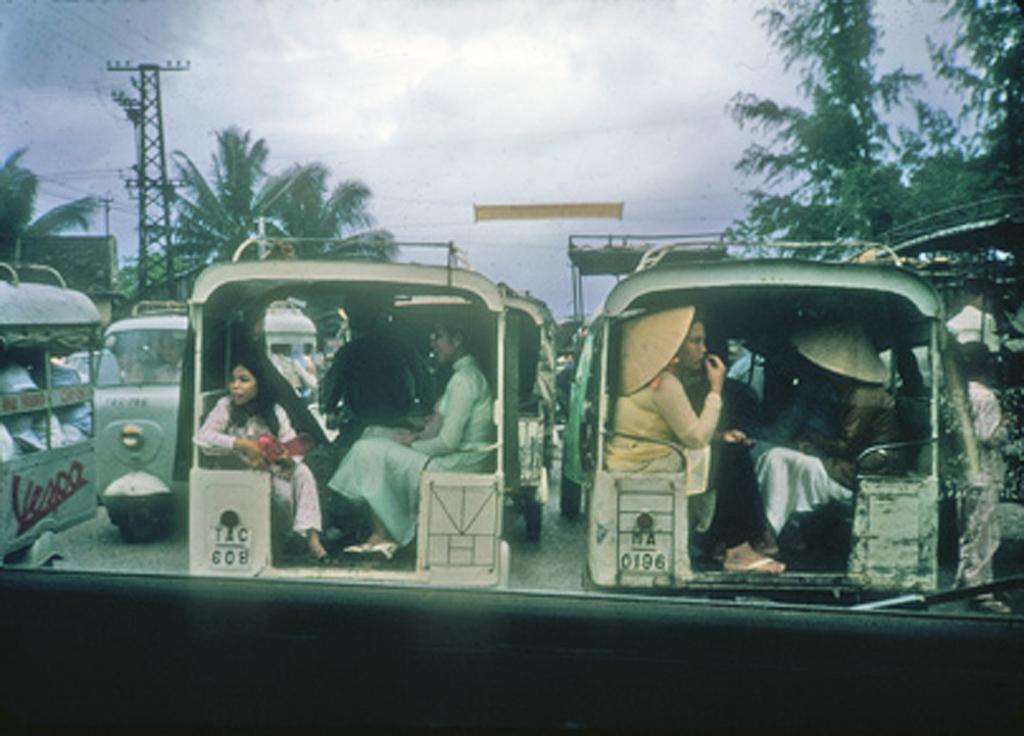In one or two sentences, can you explain what this image depicts? This image is taken in outdoors. There are many vehicles on the road, few people are sitting inside the vehicles. In the background there is a sky with clouds, a signal tower and there are many trees. 